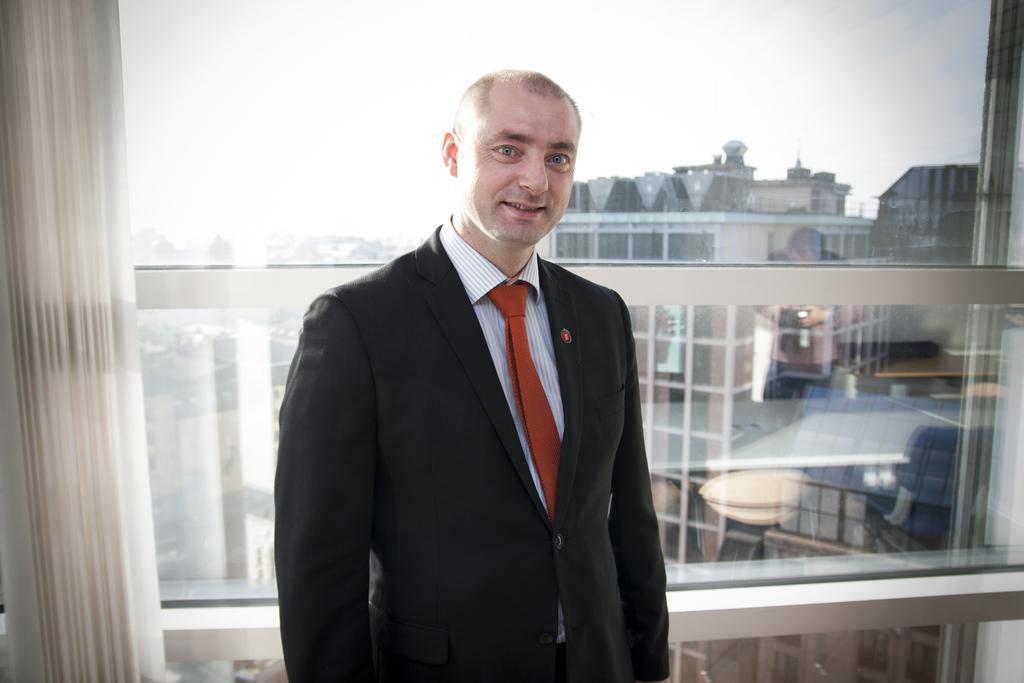In one or two sentences, can you explain what this image depicts? In the image we can see the man standing in the middle of the image and the man is wearing clothes, and he is smiling. Here we can see window curtains and the window, out of the window we can see the buildings and the sky. 